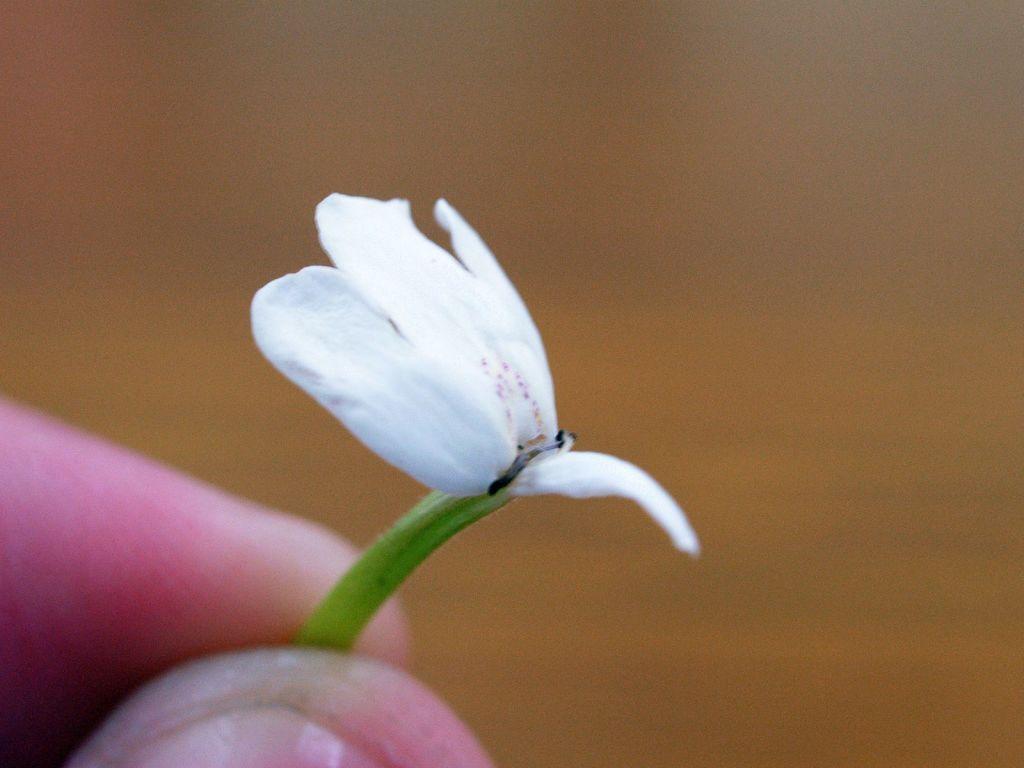Please provide a concise description of this image. On the left side, I can see a person's hand holding a flower which is in white color. The background is blurred. 